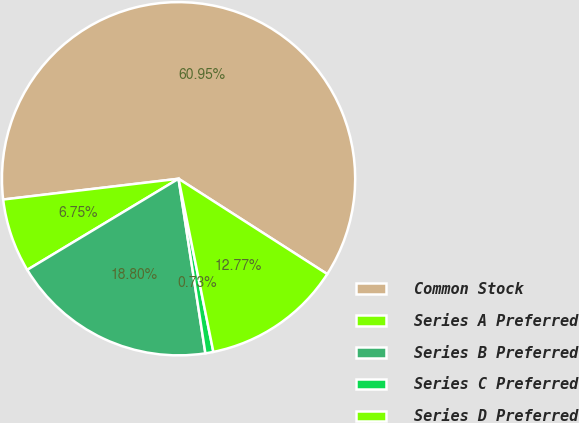Convert chart to OTSL. <chart><loc_0><loc_0><loc_500><loc_500><pie_chart><fcel>Common Stock<fcel>Series A Preferred<fcel>Series B Preferred<fcel>Series C Preferred<fcel>Series D Preferred<nl><fcel>60.95%<fcel>6.75%<fcel>18.8%<fcel>0.73%<fcel>12.77%<nl></chart> 